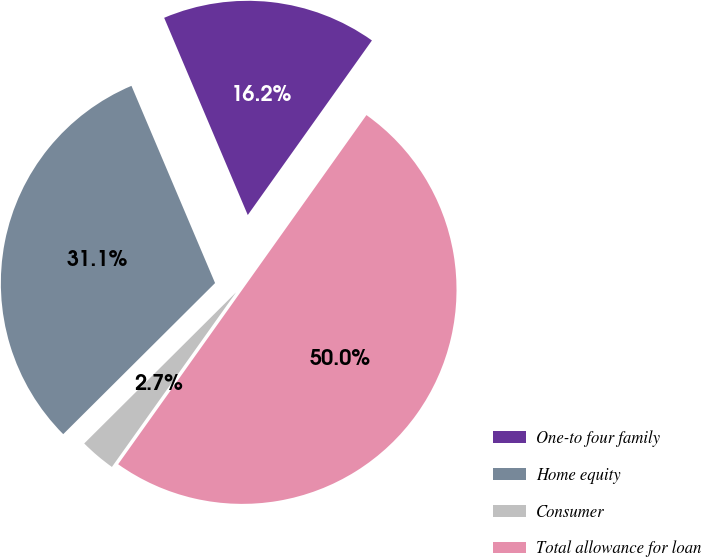Convert chart to OTSL. <chart><loc_0><loc_0><loc_500><loc_500><pie_chart><fcel>One-to four family<fcel>Home equity<fcel>Consumer<fcel>Total allowance for loan<nl><fcel>16.22%<fcel>31.08%<fcel>2.7%<fcel>50.0%<nl></chart> 